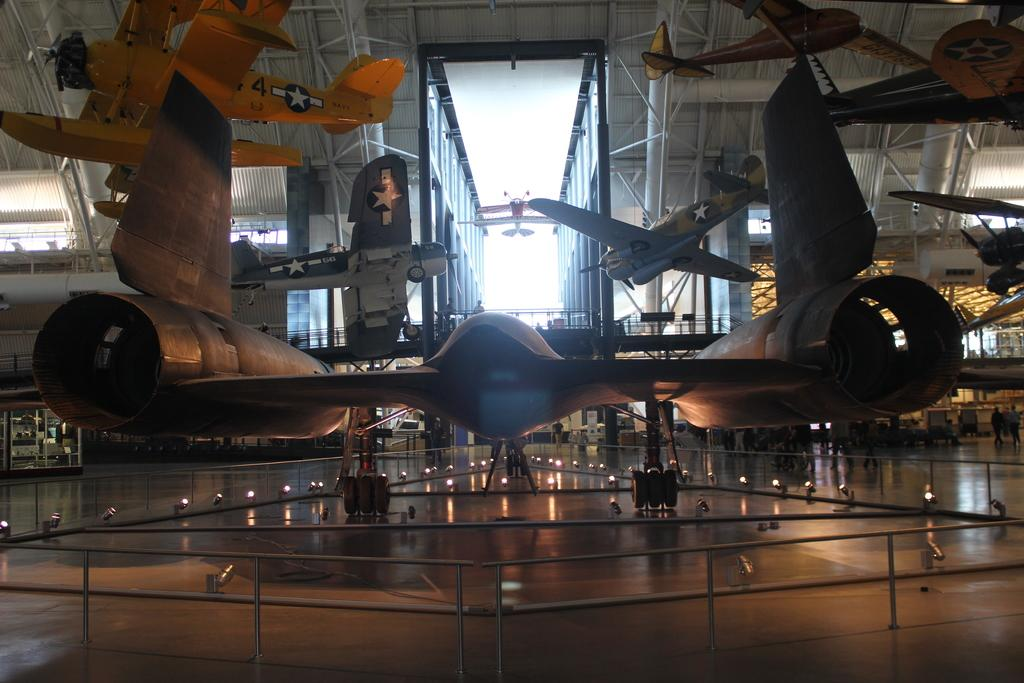What is the main subject of the image? There is an air craft in the image. Can you describe the surroundings of the main subject? There are other aircrafts visible in the background. What is the color of the sky in the image? The sky is white in color. What type of balloon is being used as a punishment for the air craft in the image? There is no balloon or punishment present in the image; it features an air craft and other aircrafts in the background with a white sky. 